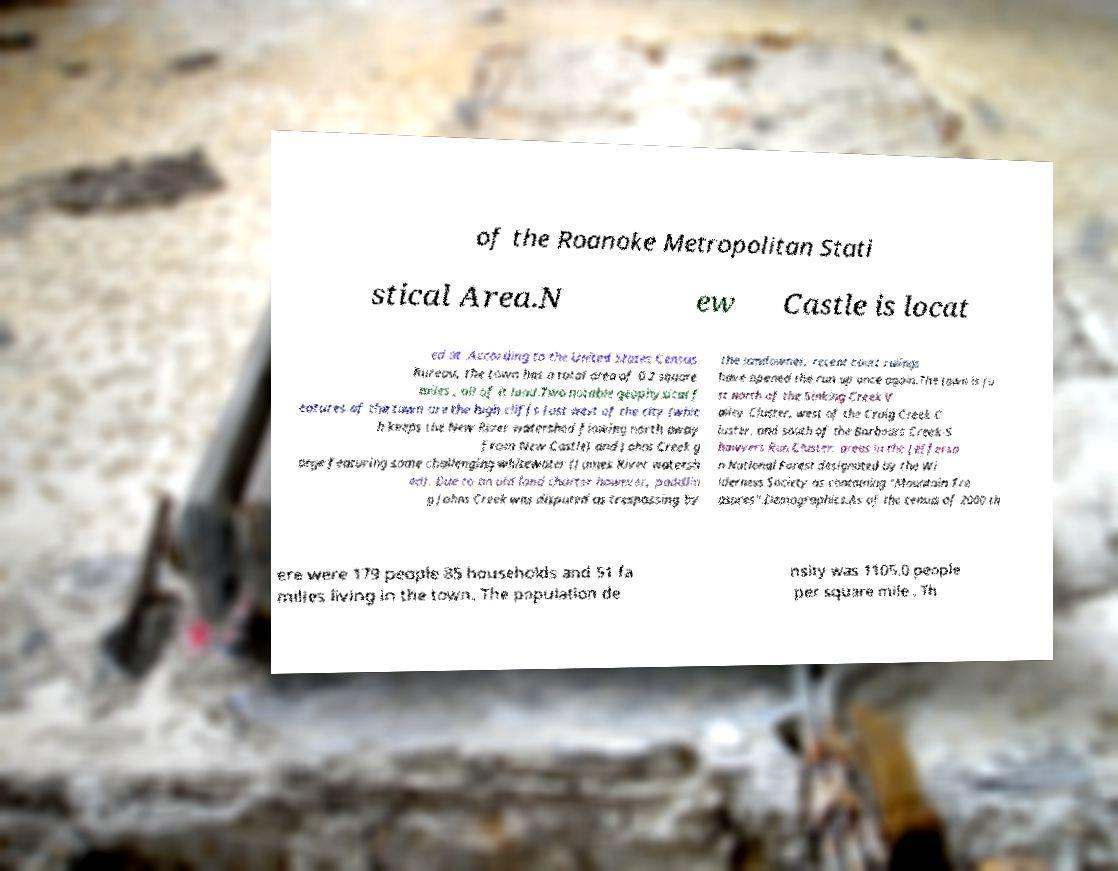Please read and relay the text visible in this image. What does it say? of the Roanoke Metropolitan Stati stical Area.N ew Castle is locat ed at .According to the United States Census Bureau, the town has a total area of 0.2 square miles , all of it land.Two notable geophysical f eatures of the town are the high cliffs just west of the city (whic h keeps the New River watershed flowing north away from New Castle) and Johns Creek g orge featuring some challenging whitewater (James River watersh ed). Due to an old land charter however, paddlin g Johns Creek was disputed as trespassing by the landowner, recent court rulings have opened the run up once again.The town is ju st north of the Sinking Creek V alley Cluster, west of the Craig Creek C luster, and south of the Barbours Creek-S hawvers Run Cluster; areas in the Jefferso n National Forest designated by the Wi lderness Society as containing "Mountain Tre asures".Demographics.As of the census of 2000 th ere were 179 people 85 households and 51 fa milies living in the town. The population de nsity was 1105.0 people per square mile . Th 